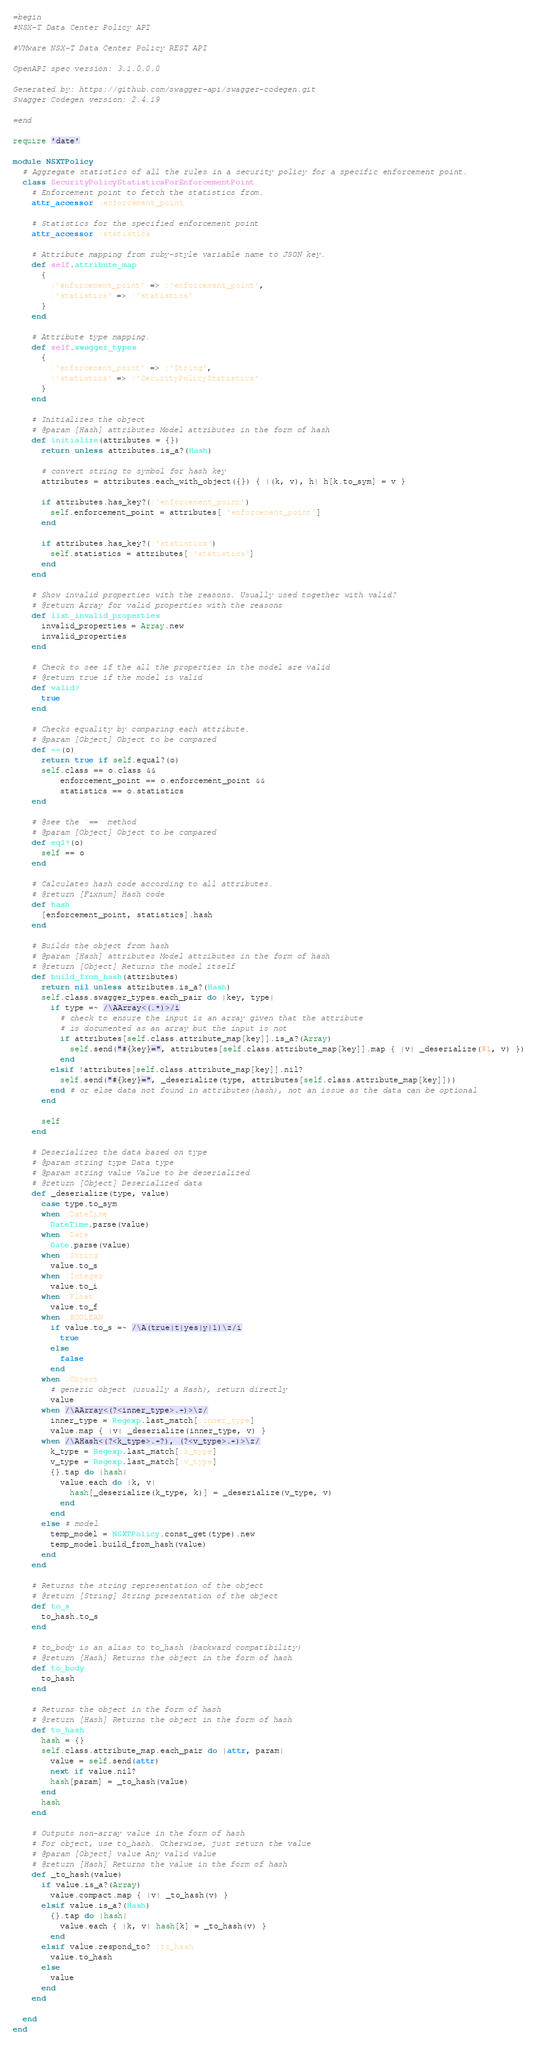Convert code to text. <code><loc_0><loc_0><loc_500><loc_500><_Ruby_>=begin
#NSX-T Data Center Policy API

#VMware NSX-T Data Center Policy REST API

OpenAPI spec version: 3.1.0.0.0

Generated by: https://github.com/swagger-api/swagger-codegen.git
Swagger Codegen version: 2.4.19

=end

require 'date'

module NSXTPolicy
  # Aggregate statistics of all the rules in a security policy for a specific enforcement point. 
  class SecurityPolicyStatisticsForEnforcementPoint
    # Enforcement point to fetch the statistics from.
    attr_accessor :enforcement_point

    # Statistics for the specified enforcement point
    attr_accessor :statistics

    # Attribute mapping from ruby-style variable name to JSON key.
    def self.attribute_map
      {
        :'enforcement_point' => :'enforcement_point',
        :'statistics' => :'statistics'
      }
    end

    # Attribute type mapping.
    def self.swagger_types
      {
        :'enforcement_point' => :'String',
        :'statistics' => :'SecurityPolicyStatistics'
      }
    end

    # Initializes the object
    # @param [Hash] attributes Model attributes in the form of hash
    def initialize(attributes = {})
      return unless attributes.is_a?(Hash)

      # convert string to symbol for hash key
      attributes = attributes.each_with_object({}) { |(k, v), h| h[k.to_sym] = v }

      if attributes.has_key?(:'enforcement_point')
        self.enforcement_point = attributes[:'enforcement_point']
      end

      if attributes.has_key?(:'statistics')
        self.statistics = attributes[:'statistics']
      end
    end

    # Show invalid properties with the reasons. Usually used together with valid?
    # @return Array for valid properties with the reasons
    def list_invalid_properties
      invalid_properties = Array.new
      invalid_properties
    end

    # Check to see if the all the properties in the model are valid
    # @return true if the model is valid
    def valid?
      true
    end

    # Checks equality by comparing each attribute.
    # @param [Object] Object to be compared
    def ==(o)
      return true if self.equal?(o)
      self.class == o.class &&
          enforcement_point == o.enforcement_point &&
          statistics == o.statistics
    end

    # @see the `==` method
    # @param [Object] Object to be compared
    def eql?(o)
      self == o
    end

    # Calculates hash code according to all attributes.
    # @return [Fixnum] Hash code
    def hash
      [enforcement_point, statistics].hash
    end

    # Builds the object from hash
    # @param [Hash] attributes Model attributes in the form of hash
    # @return [Object] Returns the model itself
    def build_from_hash(attributes)
      return nil unless attributes.is_a?(Hash)
      self.class.swagger_types.each_pair do |key, type|
        if type =~ /\AArray<(.*)>/i
          # check to ensure the input is an array given that the attribute
          # is documented as an array but the input is not
          if attributes[self.class.attribute_map[key]].is_a?(Array)
            self.send("#{key}=", attributes[self.class.attribute_map[key]].map { |v| _deserialize($1, v) })
          end
        elsif !attributes[self.class.attribute_map[key]].nil?
          self.send("#{key}=", _deserialize(type, attributes[self.class.attribute_map[key]]))
        end # or else data not found in attributes(hash), not an issue as the data can be optional
      end

      self
    end

    # Deserializes the data based on type
    # @param string type Data type
    # @param string value Value to be deserialized
    # @return [Object] Deserialized data
    def _deserialize(type, value)
      case type.to_sym
      when :DateTime
        DateTime.parse(value)
      when :Date
        Date.parse(value)
      when :String
        value.to_s
      when :Integer
        value.to_i
      when :Float
        value.to_f
      when :BOOLEAN
        if value.to_s =~ /\A(true|t|yes|y|1)\z/i
          true
        else
          false
        end
      when :Object
        # generic object (usually a Hash), return directly
        value
      when /\AArray<(?<inner_type>.+)>\z/
        inner_type = Regexp.last_match[:inner_type]
        value.map { |v| _deserialize(inner_type, v) }
      when /\AHash<(?<k_type>.+?), (?<v_type>.+)>\z/
        k_type = Regexp.last_match[:k_type]
        v_type = Regexp.last_match[:v_type]
        {}.tap do |hash|
          value.each do |k, v|
            hash[_deserialize(k_type, k)] = _deserialize(v_type, v)
          end
        end
      else # model
        temp_model = NSXTPolicy.const_get(type).new
        temp_model.build_from_hash(value)
      end
    end

    # Returns the string representation of the object
    # @return [String] String presentation of the object
    def to_s
      to_hash.to_s
    end

    # to_body is an alias to to_hash (backward compatibility)
    # @return [Hash] Returns the object in the form of hash
    def to_body
      to_hash
    end

    # Returns the object in the form of hash
    # @return [Hash] Returns the object in the form of hash
    def to_hash
      hash = {}
      self.class.attribute_map.each_pair do |attr, param|
        value = self.send(attr)
        next if value.nil?
        hash[param] = _to_hash(value)
      end
      hash
    end

    # Outputs non-array value in the form of hash
    # For object, use to_hash. Otherwise, just return the value
    # @param [Object] value Any valid value
    # @return [Hash] Returns the value in the form of hash
    def _to_hash(value)
      if value.is_a?(Array)
        value.compact.map { |v| _to_hash(v) }
      elsif value.is_a?(Hash)
        {}.tap do |hash|
          value.each { |k, v| hash[k] = _to_hash(v) }
        end
      elsif value.respond_to? :to_hash
        value.to_hash
      else
        value
      end
    end

  end
end
</code> 